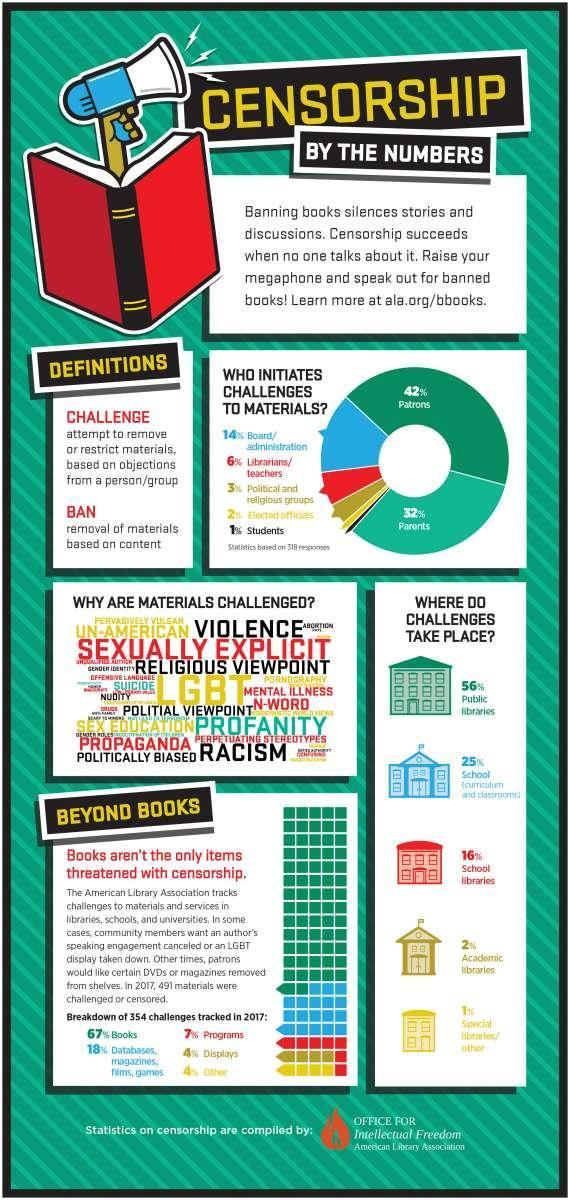Who initiates challenges to materials the most?
Answer the question with a short phrase. Patrons What percentage of challenges are not in school libraries? 84% What percentage of challenges are not in the public library? 44% What percentage of challenges are not in special libraries? 99% What percentage of challenges are not in school? 75% What percentage of challenges are not in academic libraries? 98% 